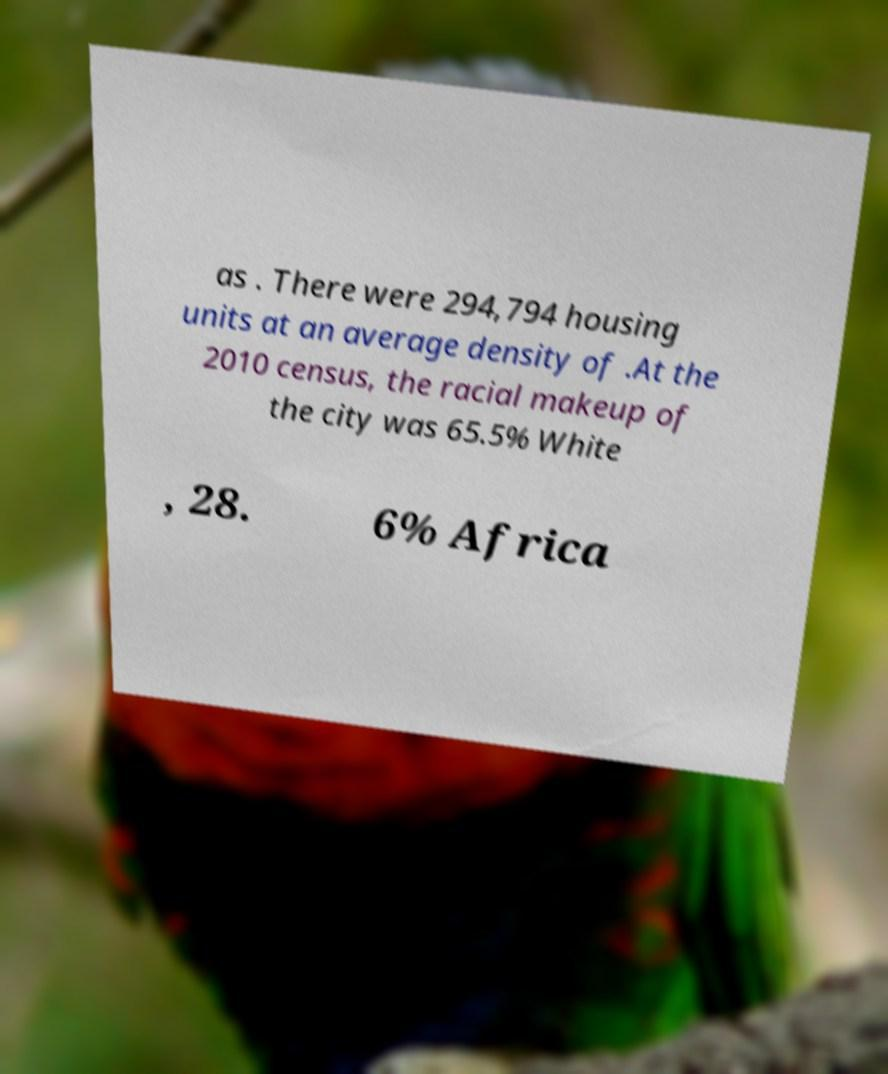Could you assist in decoding the text presented in this image and type it out clearly? as . There were 294,794 housing units at an average density of .At the 2010 census, the racial makeup of the city was 65.5% White , 28. 6% Africa 